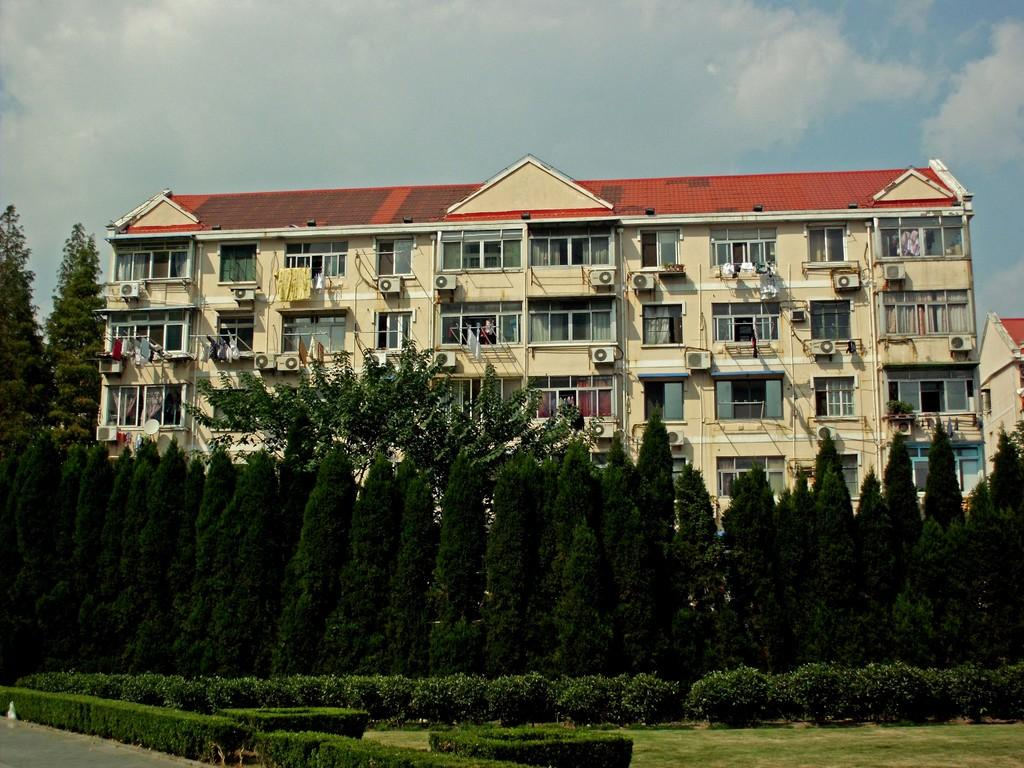What type of vegetation is in the middle of the image? There are trees in the middle of the image. What type of structure can be seen in the image? There is a big building in the image. What is visible in the background of the image? The background of the image is the sky. How many divisions can be seen in the bubble in the image? There is no bubble present in the image, so it is not possible to answer that question. 